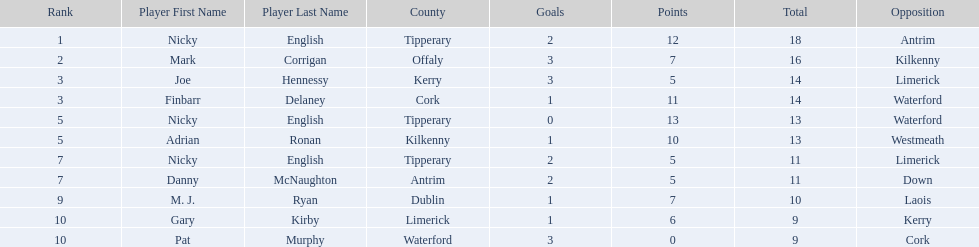What is the first name on the list? Nicky English. 